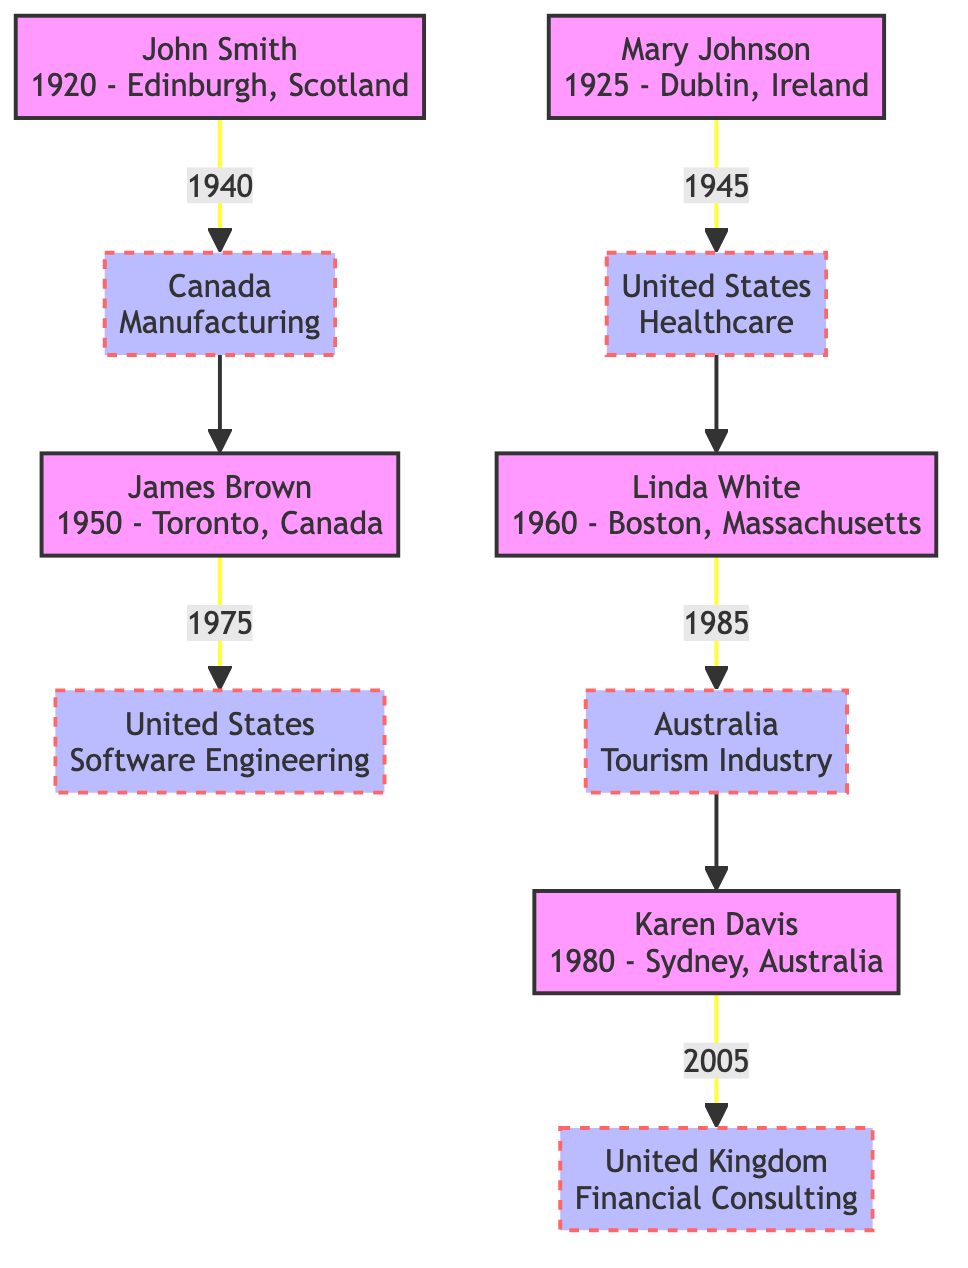What is the birthplace of John Smith? The diagram indicates that John Smith was born in Edinburgh, Scotland. This information is directly listed with his name in the corresponding node.
Answer: Edinburgh, Scotland What year did Mary Johnson migrate? The diagram shows that Mary Johnson migrated in 1945. This year is displayed in the edge connecting her node to the United States node.
Answer: 1945 What was Linda White's occupation after migrating to Australia? The diagram indicates that after migrating to Australia, Linda White worked in the tourism industry. This information is contained within the node representing her new country.
Answer: Tourism Industry How many migrations are depicted in the diagram? To determine the number of migrations, I can count the edges that connect individuals to their new countries. There are five edges representing five separate migrations.
Answer: 5 What was the migration reason for Karen Davis? The edge connecting Karen Davis to the United Kingdom states she migrated due to the globalization of the financial sector. I can extract this information directly from the migration reason attached to her node.
Answer: Globalization of the financial sector From which occupation did James Brown transition? The diagram informs that James Brown transitioned from manufacturing to software engineering. The beginning occupation is noted in the node representing his original country.
Answer: Manufacturing What is the relationship between John Smith and James Brown? In the diagram, John Smith is connected to James Brown as his ancestor, as James is the child of those who migrated from John's new country. This establishes a lineage within the family tree.
Answer: Ancestor What was the migration reason for Linda White? The diagram shows that Linda White migrated due to an economic recession in the US. I can locate this information by following the edge connecting her to Australia.
Answer: Economic recession in the US How many nodes represent people who were born in the United States? By examining the nodes, I see that two individuals are born in the United States: Mary Johnson and Linda White. Counting these nodes gives a total of two.
Answer: 2 